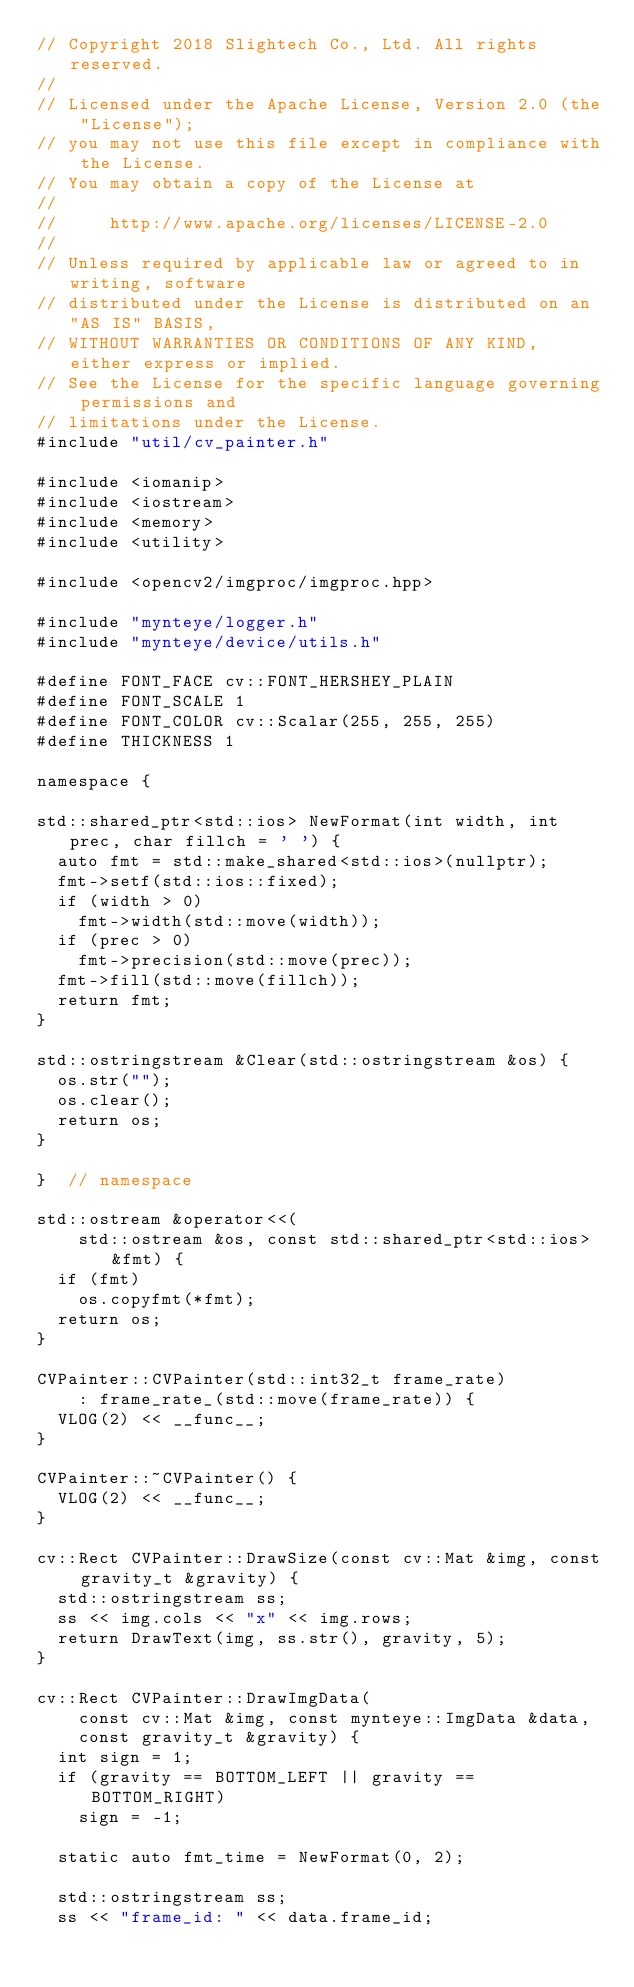Convert code to text. <code><loc_0><loc_0><loc_500><loc_500><_C++_>// Copyright 2018 Slightech Co., Ltd. All rights reserved.
//
// Licensed under the Apache License, Version 2.0 (the "License");
// you may not use this file except in compliance with the License.
// You may obtain a copy of the License at
//
//     http://www.apache.org/licenses/LICENSE-2.0
//
// Unless required by applicable law or agreed to in writing, software
// distributed under the License is distributed on an "AS IS" BASIS,
// WITHOUT WARRANTIES OR CONDITIONS OF ANY KIND, either express or implied.
// See the License for the specific language governing permissions and
// limitations under the License.
#include "util/cv_painter.h"

#include <iomanip>
#include <iostream>
#include <memory>
#include <utility>

#include <opencv2/imgproc/imgproc.hpp>

#include "mynteye/logger.h"
#include "mynteye/device/utils.h"

#define FONT_FACE cv::FONT_HERSHEY_PLAIN
#define FONT_SCALE 1
#define FONT_COLOR cv::Scalar(255, 255, 255)
#define THICKNESS 1

namespace {

std::shared_ptr<std::ios> NewFormat(int width, int prec, char fillch = ' ') {
  auto fmt = std::make_shared<std::ios>(nullptr);
  fmt->setf(std::ios::fixed);
  if (width > 0)
    fmt->width(std::move(width));
  if (prec > 0)
    fmt->precision(std::move(prec));
  fmt->fill(std::move(fillch));
  return fmt;
}

std::ostringstream &Clear(std::ostringstream &os) {
  os.str("");
  os.clear();
  return os;
}

}  // namespace

std::ostream &operator<<(
    std::ostream &os, const std::shared_ptr<std::ios> &fmt) {
  if (fmt)
    os.copyfmt(*fmt);
  return os;
}

CVPainter::CVPainter(std::int32_t frame_rate)
    : frame_rate_(std::move(frame_rate)) {
  VLOG(2) << __func__;
}

CVPainter::~CVPainter() {
  VLOG(2) << __func__;
}

cv::Rect CVPainter::DrawSize(const cv::Mat &img, const gravity_t &gravity) {
  std::ostringstream ss;
  ss << img.cols << "x" << img.rows;
  return DrawText(img, ss.str(), gravity, 5);
}

cv::Rect CVPainter::DrawImgData(
    const cv::Mat &img, const mynteye::ImgData &data,
    const gravity_t &gravity) {
  int sign = 1;
  if (gravity == BOTTOM_LEFT || gravity == BOTTOM_RIGHT)
    sign = -1;

  static auto fmt_time = NewFormat(0, 2);

  std::ostringstream ss;
  ss << "frame_id: " << data.frame_id;</code> 